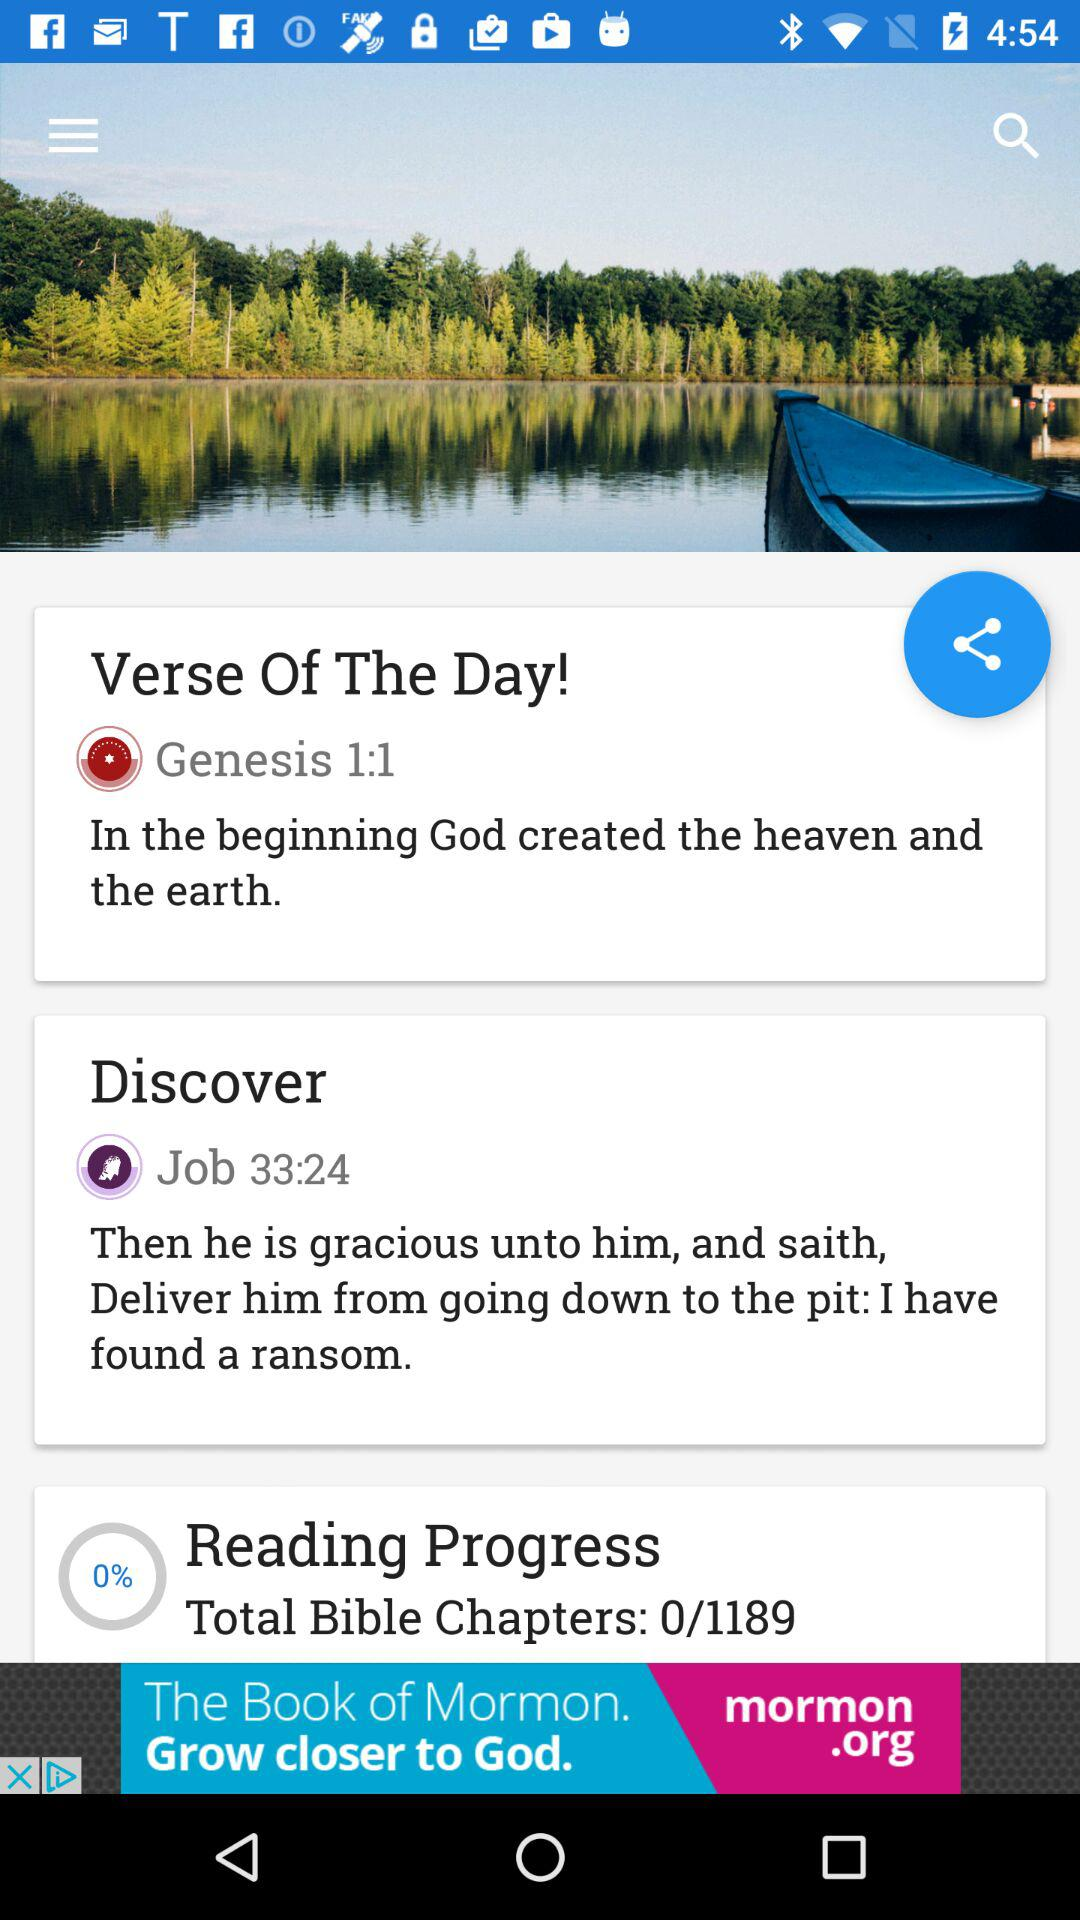How many bible chapters in total are there in the "Reading Progress"? There are 1189 bible chapters in total in the "Reading Progress". 